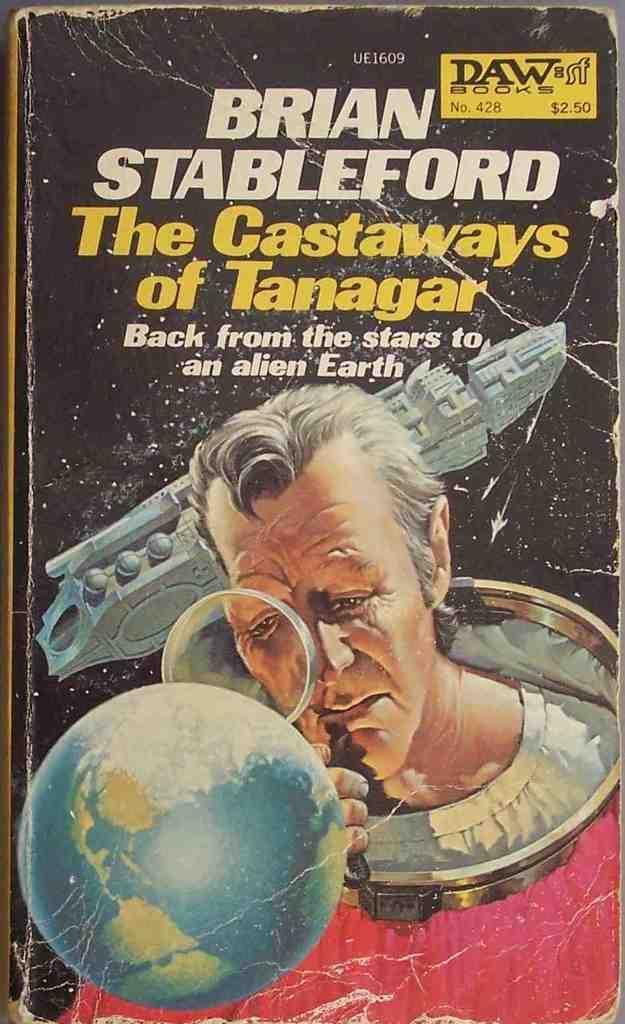Provide a one-sentence caption for the provided image. a paperback copy of The Castaways of Tanagar by Brian Stableford. 